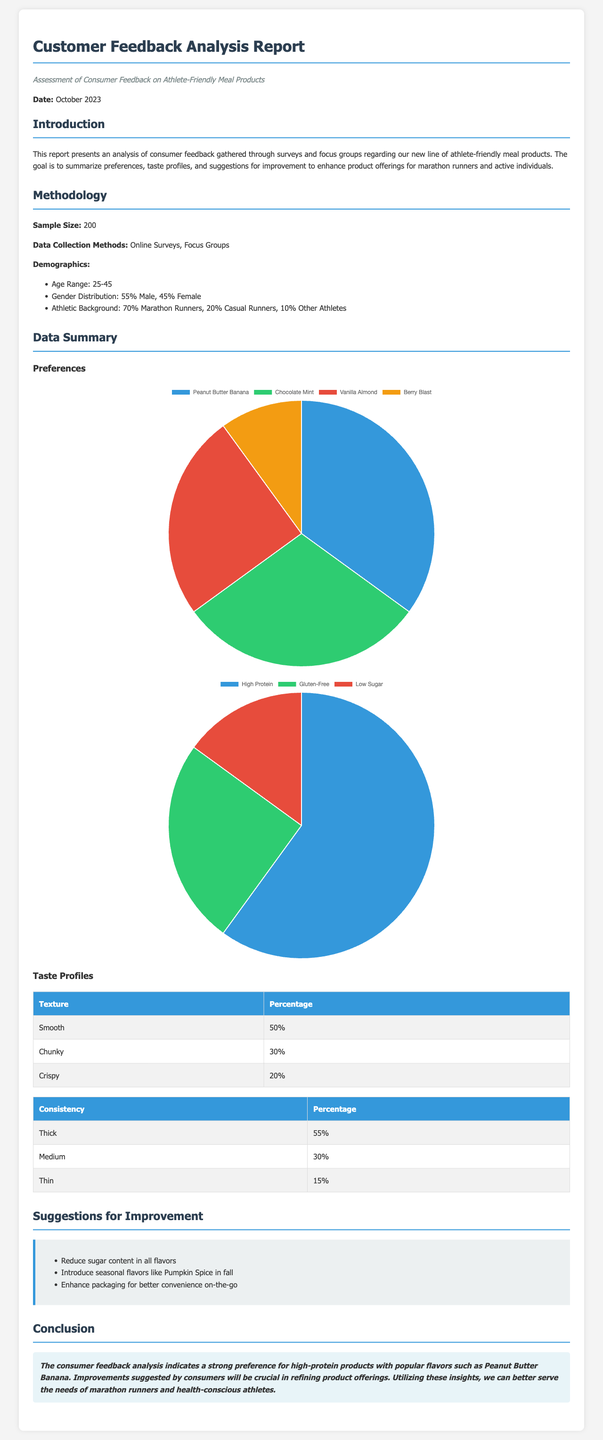what is the sample size of the study? The sample size refers to the number of participants in the feedback analysis, mentioned in the methodology section.
Answer: 200 what percentage of respondents are marathon runners? This percentage is detailed in the demographics section, indicating the athletic background of the sample.
Answer: 70% which flavor had the highest preference? The flavor with the highest preference is specified in the flavor preferences section of the data summary.
Answer: Peanut Butter Banana what are the three required nutritional features? The required nutritional features are listed in the nutritional features chart data.
Answer: High Protein, Gluten-Free, Low Sugar what percentage of respondents preferred a thick consistency? This percentage is found within the consistency table detailing taste profiles.
Answer: 55% which suggestion was made regarding packaging? Consumer suggestions for improvement are outlined in a section dedicated to suggestions.
Answer: Enhance packaging for better convenience on-the-go how many flavors are listed in the flavor preferences chart? The chart displays specific flavors that have been rated by respondents, indicating the variety offered.
Answer: Four what is the date of the report? The report includes a date that helps contextualize the timing of the research.
Answer: October 2023 